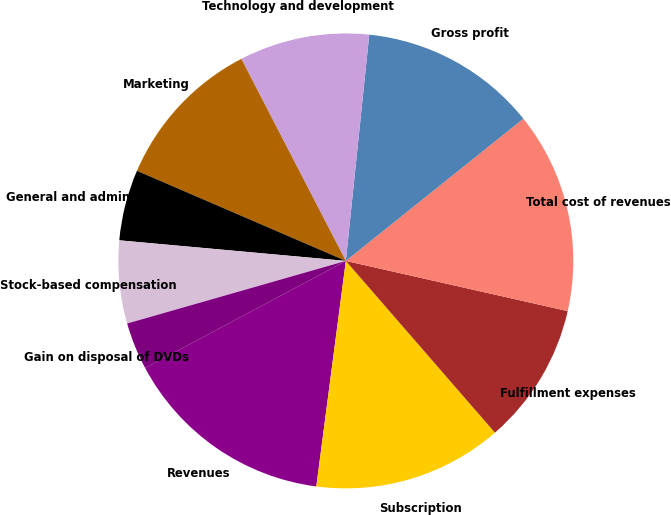Convert chart. <chart><loc_0><loc_0><loc_500><loc_500><pie_chart><fcel>Revenues<fcel>Subscription<fcel>Fulfillment expenses<fcel>Total cost of revenues<fcel>Gross profit<fcel>Technology and development<fcel>Marketing<fcel>General and administrative<fcel>Stock-based compensation<fcel>Gain on disposal of DVDs<nl><fcel>15.13%<fcel>13.45%<fcel>10.08%<fcel>14.29%<fcel>12.61%<fcel>9.24%<fcel>10.92%<fcel>5.04%<fcel>5.88%<fcel>3.36%<nl></chart> 